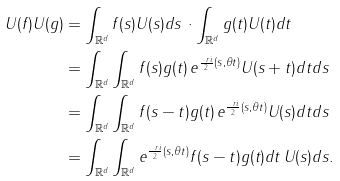Convert formula to latex. <formula><loc_0><loc_0><loc_500><loc_500>U ( f ) U ( g ) & = \int _ { { \mathbb { R } } ^ { d } } f ( s ) U ( s ) d s \, \cdot \int _ { { \mathbb { R } } ^ { d } } g ( t ) U ( t ) d t \\ & = \int _ { { \mathbb { R } } ^ { d } } \int _ { { \mathbb { R } } ^ { d } } f ( s ) g ( t ) \, e ^ { \frac { \ r i } { 2 } ( s , \theta t ) } U ( s + t ) d t d s \\ & = \int _ { { \mathbb { R } } ^ { d } } \int _ { { \mathbb { R } } ^ { d } } f ( s - t ) g ( t ) \, e ^ { \frac { \ r i } { 2 } ( s , \theta t ) } U ( s ) d t d s \\ & = \int _ { { \mathbb { R } } ^ { d } } \int _ { { \mathbb { R } } ^ { d } } e ^ { \frac { \ r i } { 2 } ( s , \theta t ) } f ( s - t ) g ( t ) d t \, U ( s ) d s .</formula> 